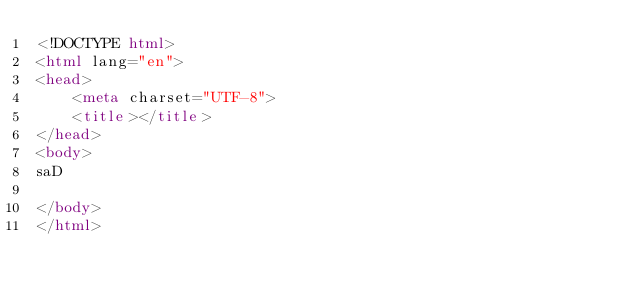<code> <loc_0><loc_0><loc_500><loc_500><_HTML_><!DOCTYPE html>
<html lang="en">
<head>
    <meta charset="UTF-8">
    <title></title>
</head>
<body>
saD

</body>
</html></code> 